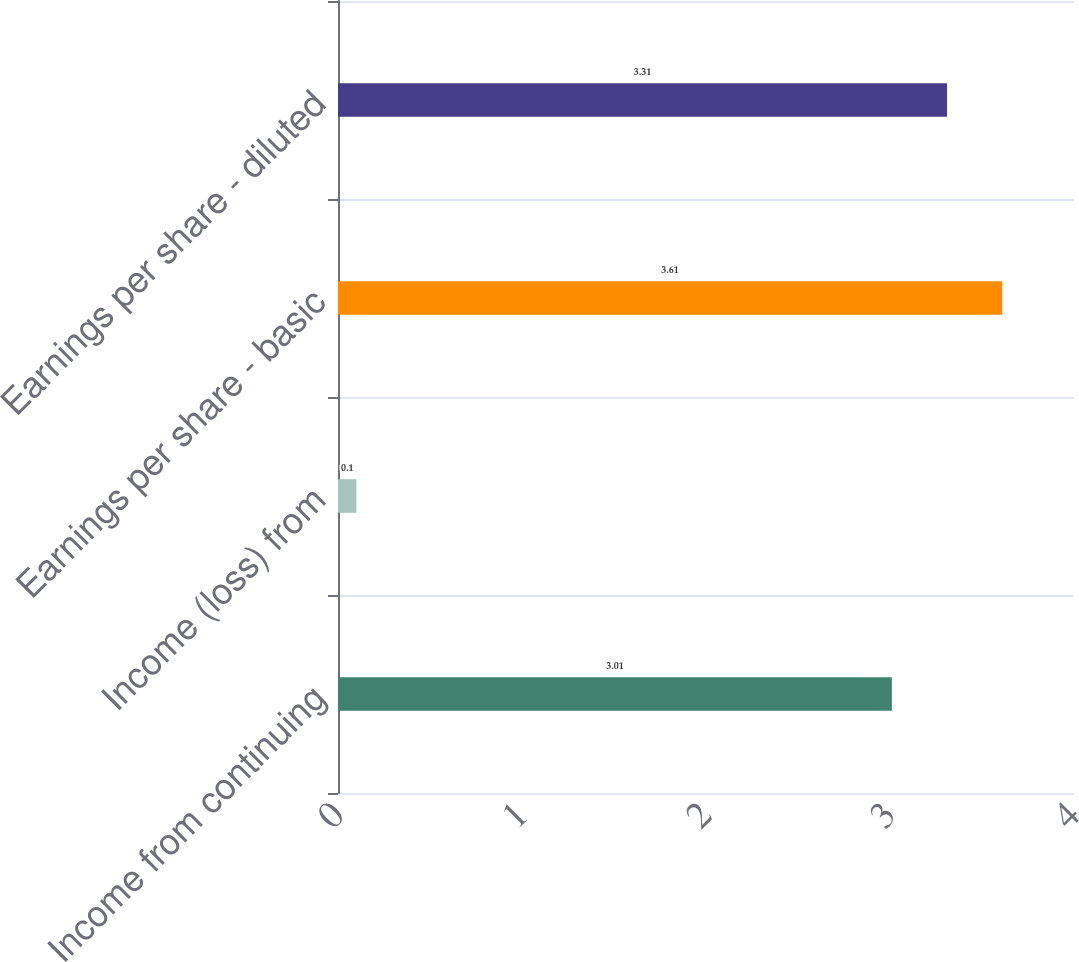Convert chart to OTSL. <chart><loc_0><loc_0><loc_500><loc_500><bar_chart><fcel>Income from continuing<fcel>Income (loss) from<fcel>Earnings per share - basic<fcel>Earnings per share - diluted<nl><fcel>3.01<fcel>0.1<fcel>3.61<fcel>3.31<nl></chart> 